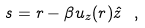<formula> <loc_0><loc_0><loc_500><loc_500>s = r - \beta u _ { z } ( r ) \hat { z } \ ,</formula> 